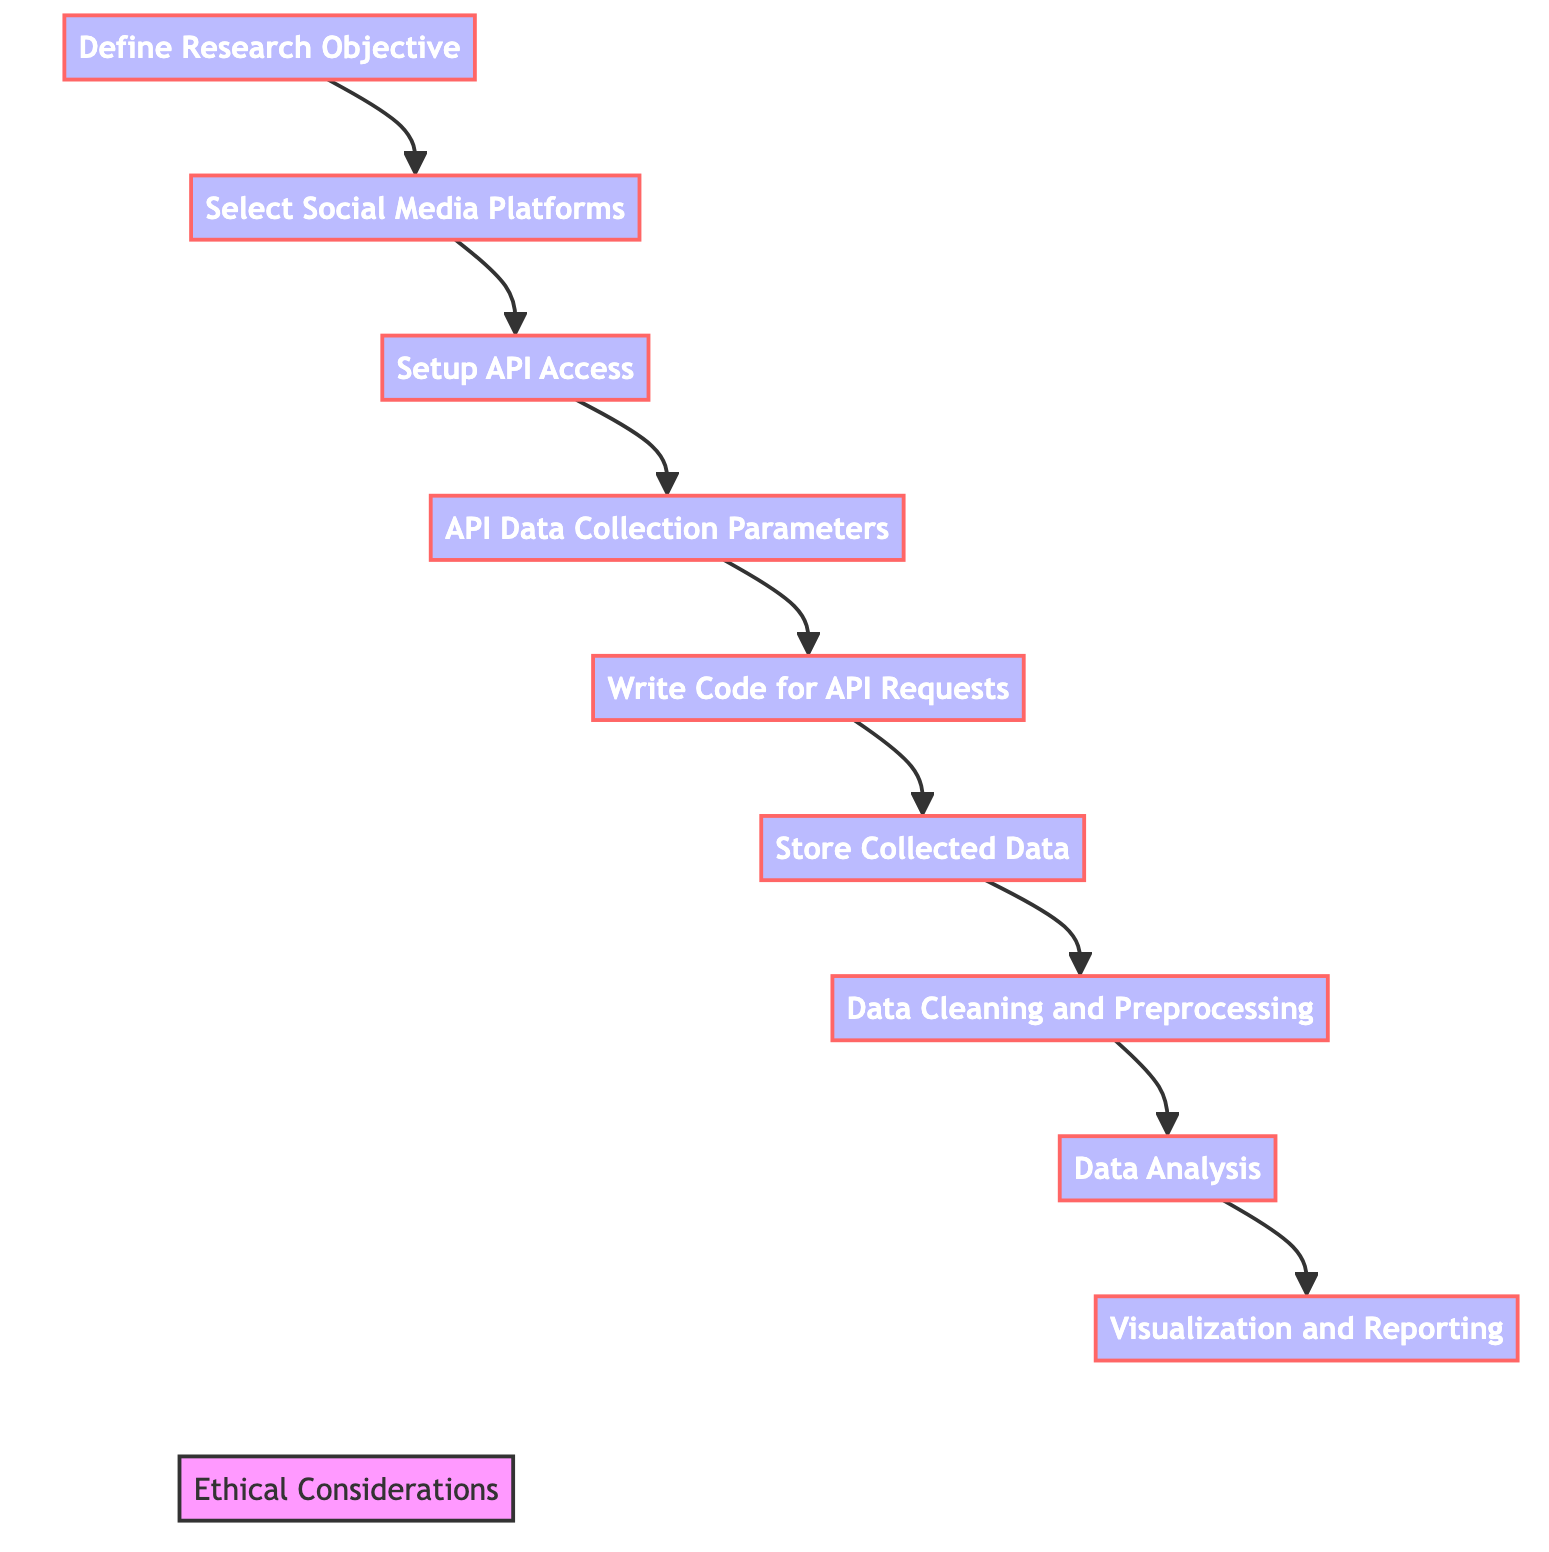What is the first step in the process? The diagram shows that the first step is "Define Research Objective." This is indicated by the order of the nodes, starting from A at the top.
Answer: Define Research Objective How many steps are there in the diagram? By counting the distinct process nodes from A to I, there are a total of eight steps in the main flow of the diagram.
Answer: Eight Which step comes after "Select Social Media Platforms"? According to the flowchart, "Setup API Access" directly follows "Select Social Media Platforms," indicated by the directed arrow from B to C.
Answer: Setup API Access What step is concerned with removing duplicates? The step that deals with removing duplicates is "Data Cleaning and Preprocessing." This is pointed out by the flow from F to G in the diagram.
Answer: Data Cleaning and Preprocessing Which step shows the ethical considerations? The ethical considerations are represented by node J and are associated with each of the main steps A, B, C, D, E, F, G, H, and I, as indicated by the dotted lines connecting them to J.
Answer: Ethical Considerations What step requires writing scripts? "Write Code for API Requests" is the step where scripts are written, as explicitly stated in node E of the diagram.
Answer: Write Code for API Requests What is the final step in the analysis process? The last step indicated in the main flow of the diagram is "Visualization and Reporting," shown as node I at the end of the sequence.
Answer: Visualization and Reporting Which two steps are directly linked to "Data Analysis"? The steps that are directly linked to "Data Analysis" are "Data Cleaning and Preprocessing" and "Visualization and Reporting," as G flows into H and H flows into I.
Answer: Data Cleaning and Preprocessing and Visualization and Reporting What common aspect do all steps share in relation to "Ethical Considerations"? All steps (A through I) are connected to "Ethical Considerations" by dotted lines, indicating that ethical guidelines apply to every part of the process.
Answer: Compliance with ethical guidelines 